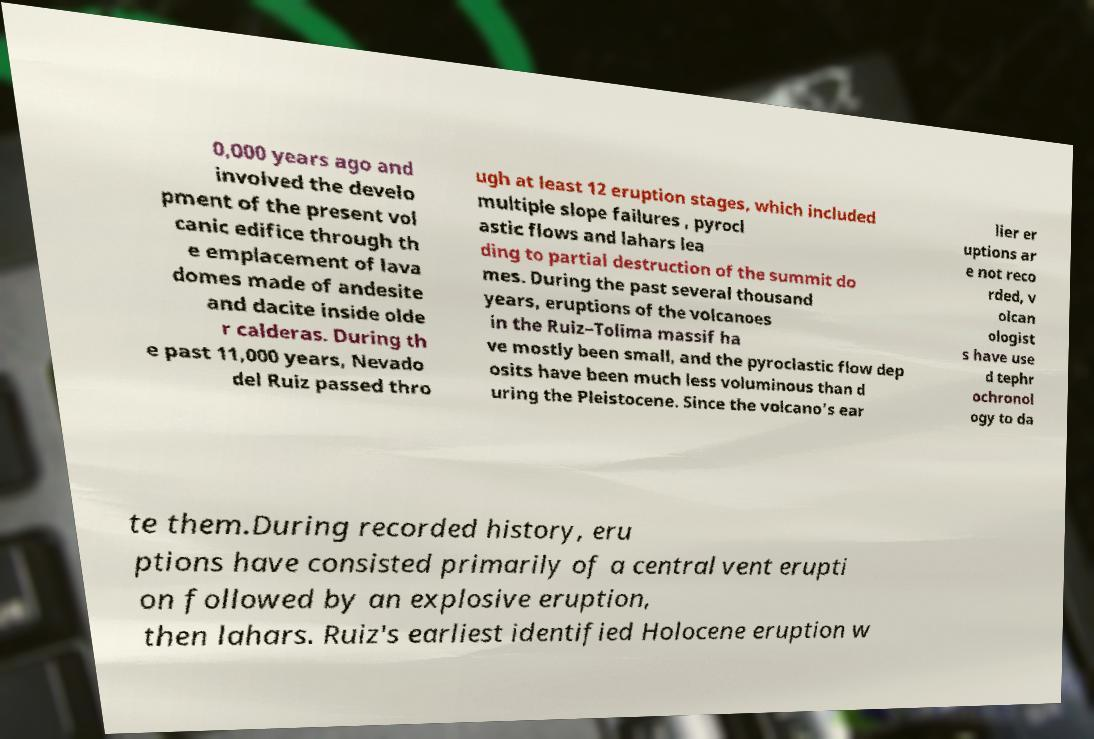For documentation purposes, I need the text within this image transcribed. Could you provide that? 0,000 years ago and involved the develo pment of the present vol canic edifice through th e emplacement of lava domes made of andesite and dacite inside olde r calderas. During th e past 11,000 years, Nevado del Ruiz passed thro ugh at least 12 eruption stages, which included multiple slope failures , pyrocl astic flows and lahars lea ding to partial destruction of the summit do mes. During the past several thousand years, eruptions of the volcanoes in the Ruiz–Tolima massif ha ve mostly been small, and the pyroclastic flow dep osits have been much less voluminous than d uring the Pleistocene. Since the volcano's ear lier er uptions ar e not reco rded, v olcan ologist s have use d tephr ochronol ogy to da te them.During recorded history, eru ptions have consisted primarily of a central vent erupti on followed by an explosive eruption, then lahars. Ruiz's earliest identified Holocene eruption w 